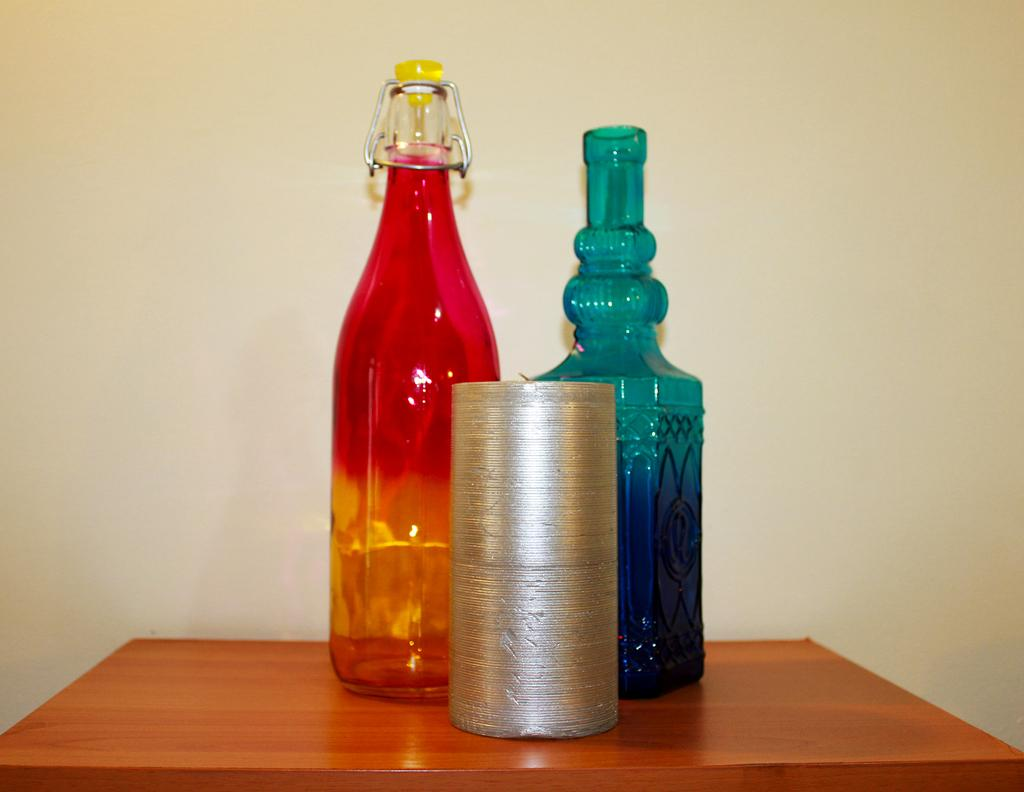How many bottles are visible in the image? There are 2 bottles in the image. Where are the bottles located? The bottles are on a table in the image. What else can be seen in the image besides the bottles? There is a wall visible in the image. What type of lettuce is growing on the wall in the image? There is no lettuce present in the image; it only features bottles on a table and a visible wall. What type of punishment is being administered to the bottles in the image? There is no punishment being administered to the bottles in the image; they are simply sitting on a table. Can you see an airplane in the image? There is no airplane present in the image; it only features bottles on a table and a visible wall. 